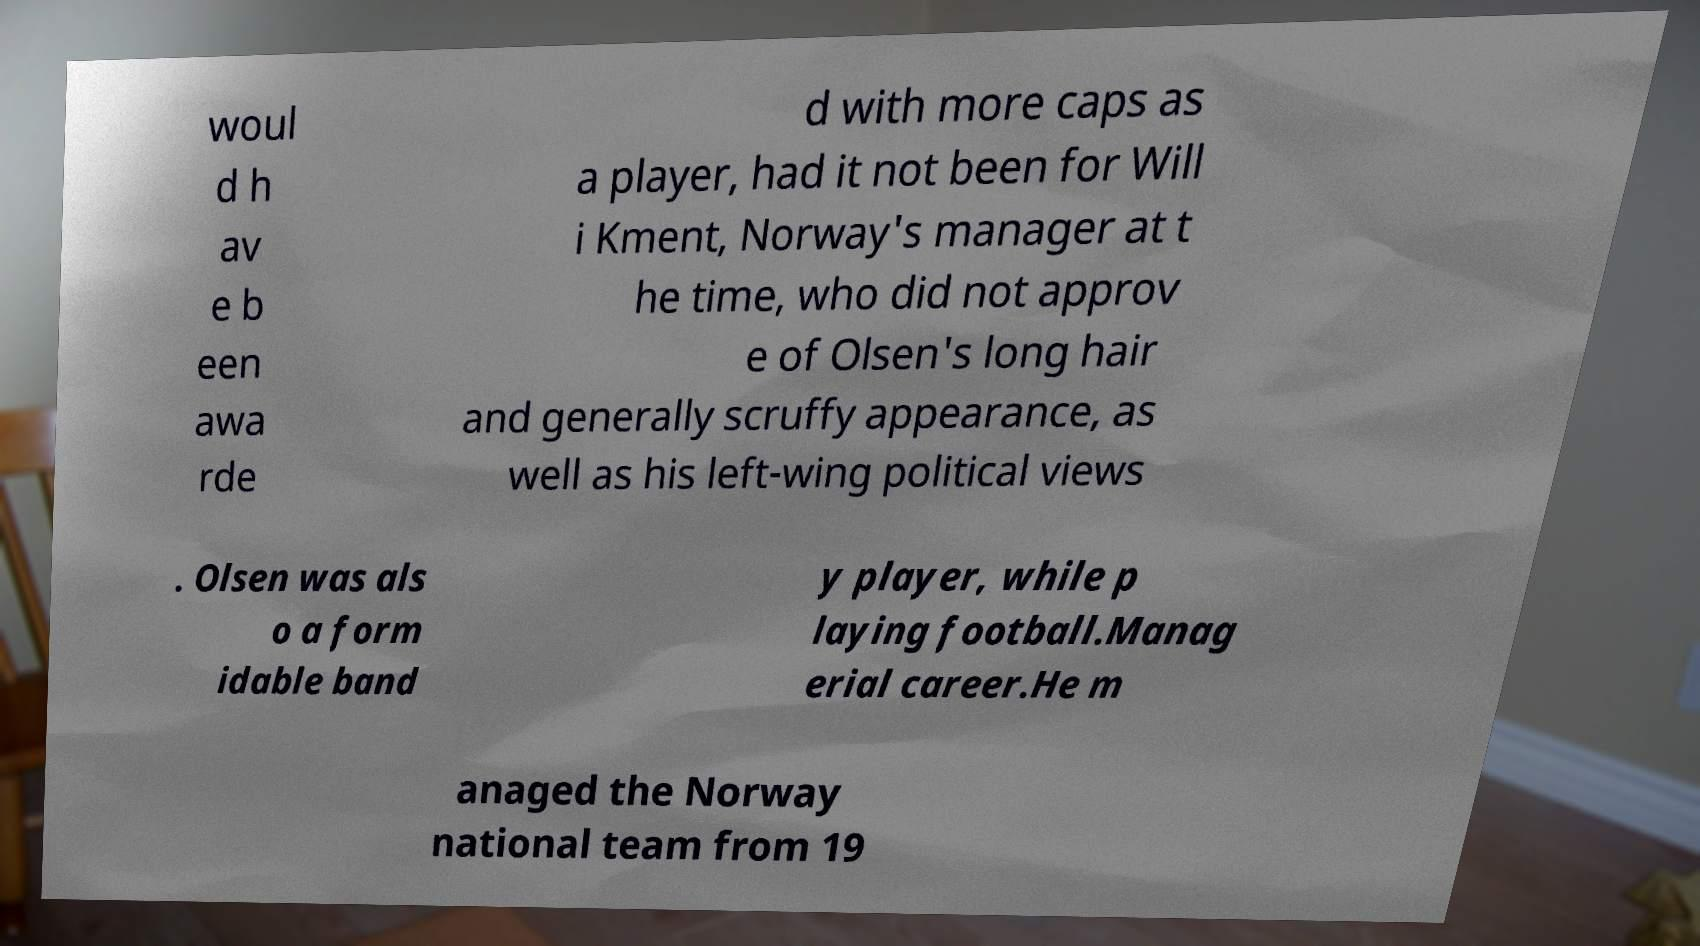Please read and relay the text visible in this image. What does it say? woul d h av e b een awa rde d with more caps as a player, had it not been for Will i Kment, Norway's manager at t he time, who did not approv e of Olsen's long hair and generally scruffy appearance, as well as his left-wing political views . Olsen was als o a form idable band y player, while p laying football.Manag erial career.He m anaged the Norway national team from 19 